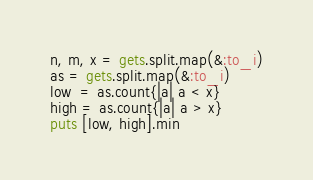<code> <loc_0><loc_0><loc_500><loc_500><_Ruby_>n, m, x = gets.split.map(&:to_i)
as = gets.split.map(&:to_i)
low  = as.count{|a| a < x}
high = as.count{|a| a > x}
puts [low, high].min</code> 